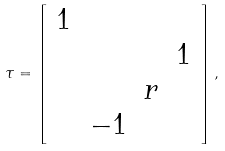Convert formula to latex. <formula><loc_0><loc_0><loc_500><loc_500>\tau = \left [ \begin{array} { c c c c } 1 & & & \\ & & & 1 \\ & & r & \\ & - 1 & & \end{array} \right ] ,</formula> 